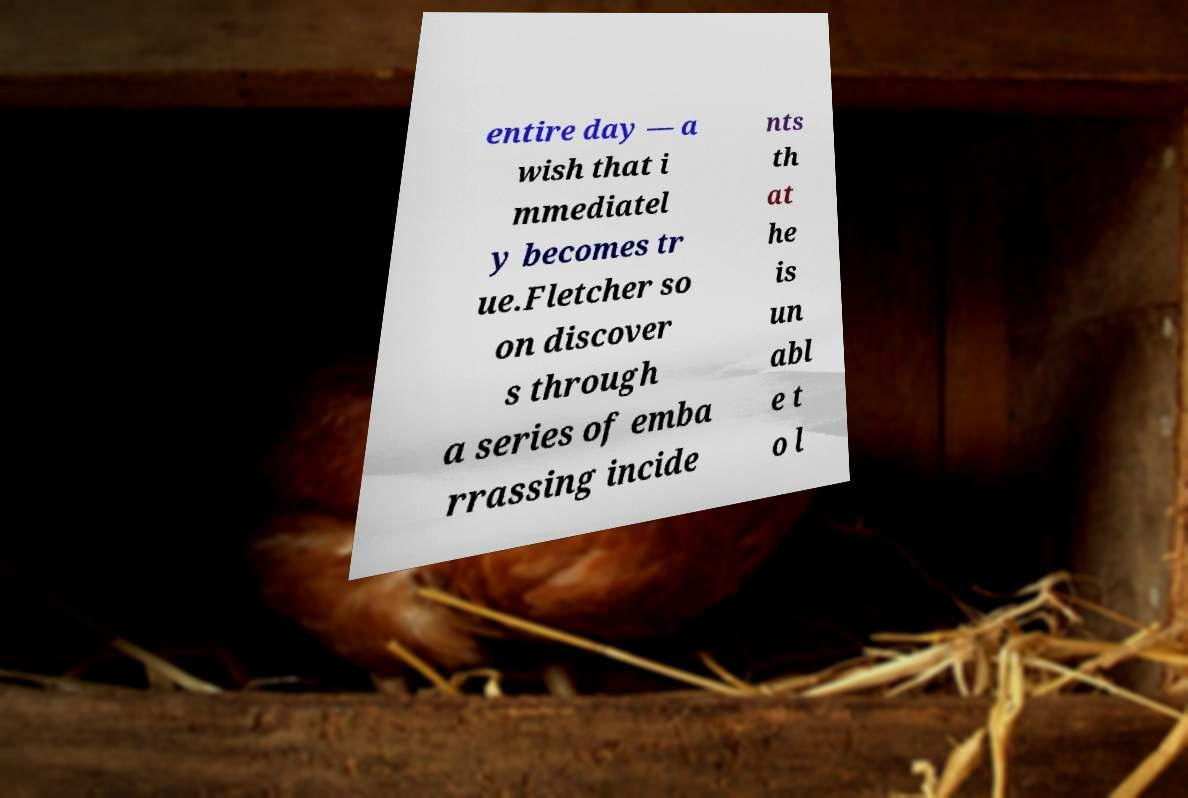Could you extract and type out the text from this image? entire day — a wish that i mmediatel y becomes tr ue.Fletcher so on discover s through a series of emba rrassing incide nts th at he is un abl e t o l 